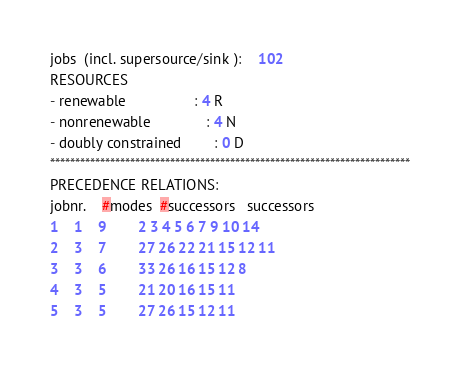Convert code to text. <code><loc_0><loc_0><loc_500><loc_500><_ObjectiveC_>jobs  (incl. supersource/sink ):	102
RESOURCES
- renewable                 : 4 R
- nonrenewable              : 4 N
- doubly constrained        : 0 D
************************************************************************
PRECEDENCE RELATIONS:
jobnr.    #modes  #successors   successors
1	1	9		2 3 4 5 6 7 9 10 14 
2	3	7		27 26 22 21 15 12 11 
3	3	6		33 26 16 15 12 8 
4	3	5		21 20 16 15 11 
5	3	5		27 26 15 12 11 </code> 